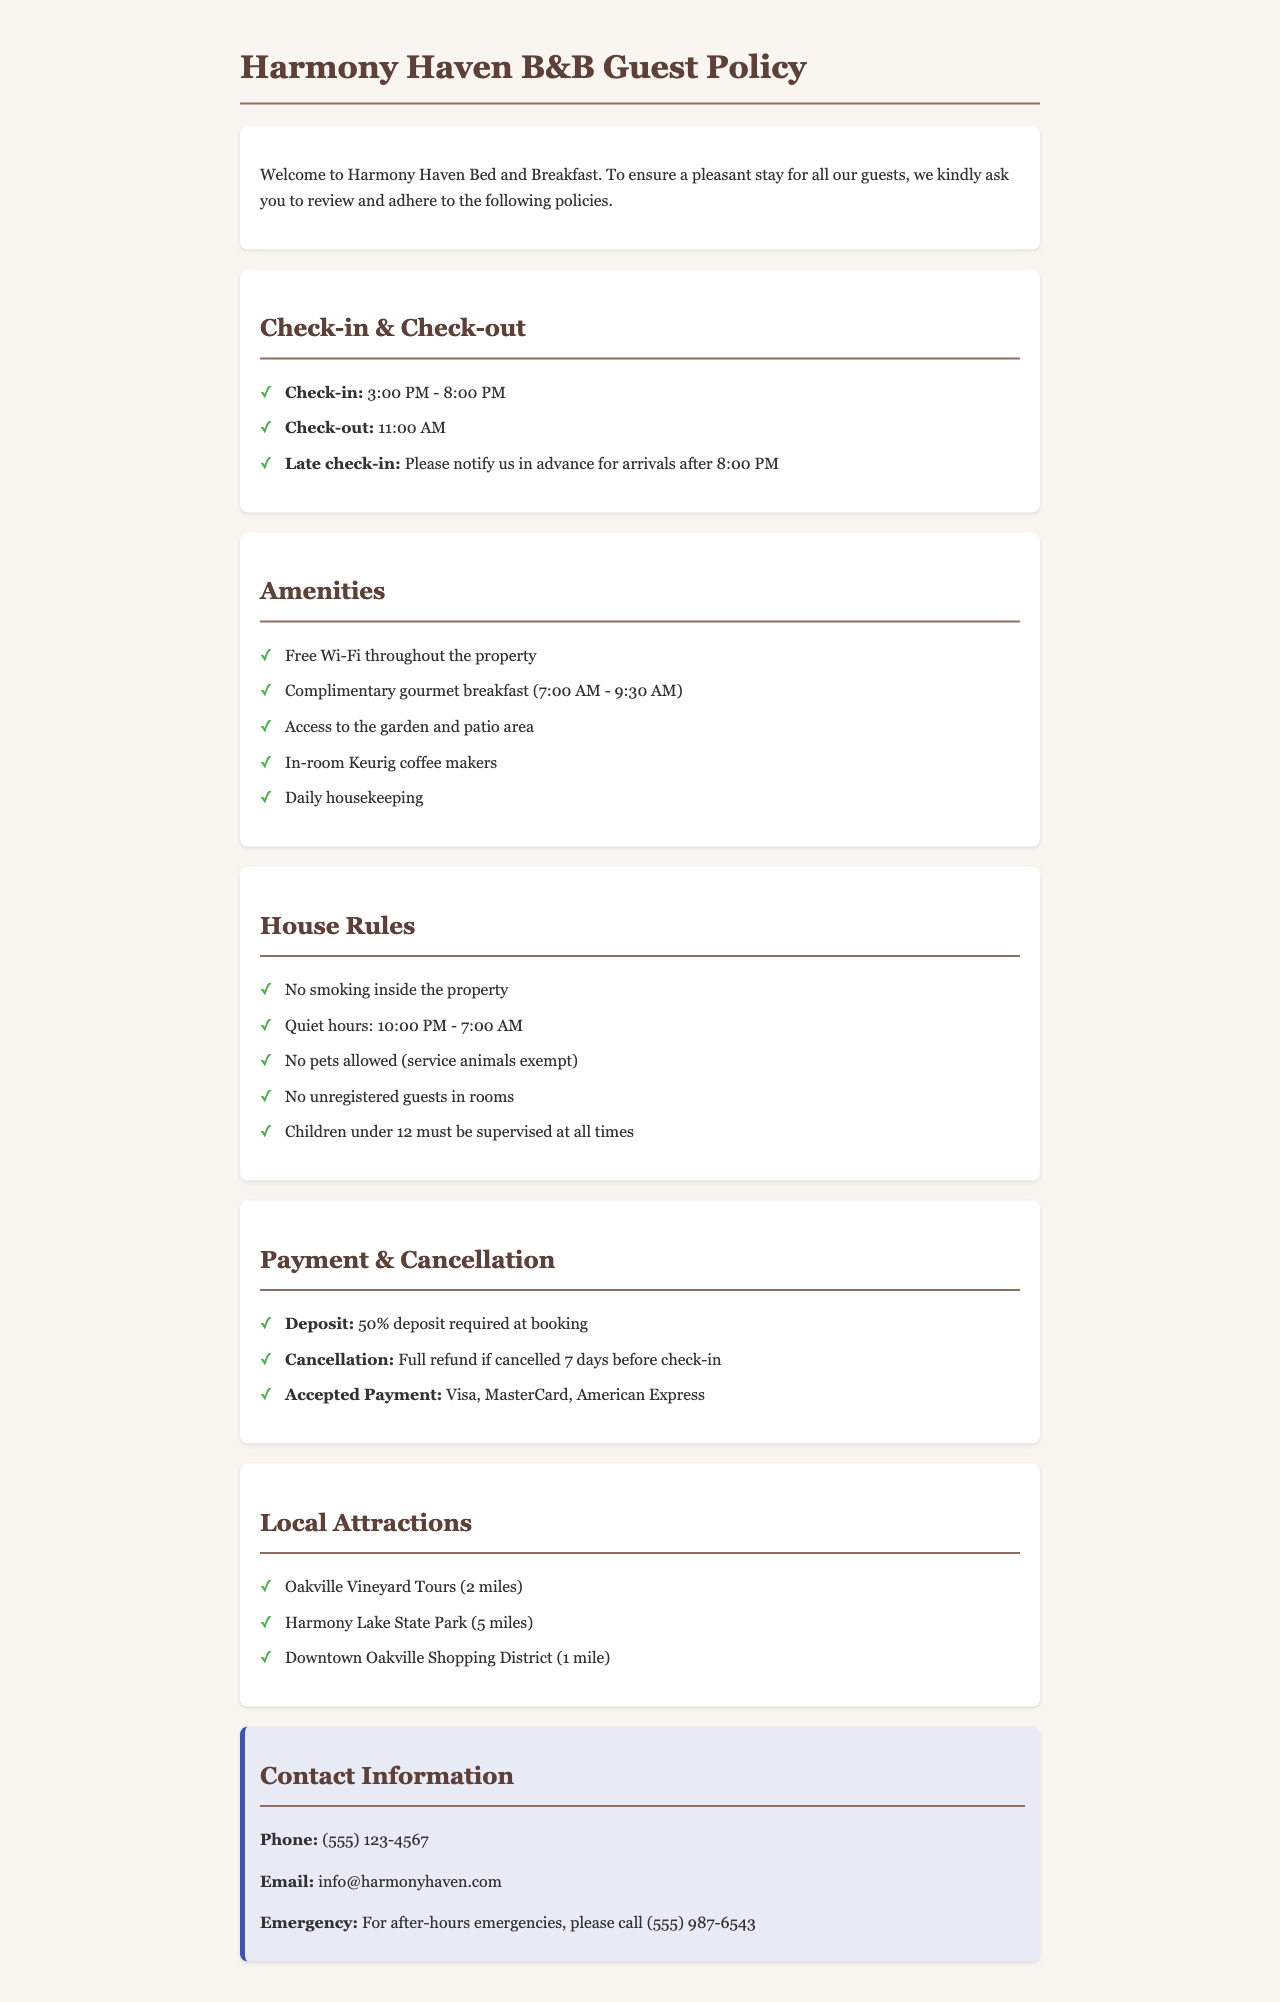What are the check-in hours? The check-in hours are specified in the document, which states that check-in is from 3:00 PM to 8:00 PM.
Answer: 3:00 PM - 8:00 PM What is the cancellation policy? The cancellation policy describes that guests will receive a full refund if cancelled 7 days before check-in.
Answer: Full refund if cancelled 7 days before check-in What is included in the complimentary breakfast? The document mentions that a complimentary gourmet breakfast is included, highlighting its time frame and nature.
Answer: Complimentary gourmet breakfast Is smoking allowed inside the property? The house rules specify that no smoking is allowed inside the property, making it clear that this is prohibited.
Answer: No How many local attractions are listed? By counting the number of attractions mentioned in the local attractions section, we can determine the total number.
Answer: 3 What amenities are available for guests? The document enumerates a series of amenities provided to guests, including specifics like Wi-Fi and housekeeping services.
Answer: Free Wi-Fi, Complementary gourmet breakfast, Access to the garden and patio area, In-room Keurig coffee makers, Daily housekeeping What time does quiet hours start? Quiet hours are defined in the house rules section, indicating the time at which they begin and end.
Answer: 10:00 PM What forms of payment are accepted? The document explicitly lists the forms of payment that are accepted for transactions.
Answer: Visa, MasterCard, American Express 